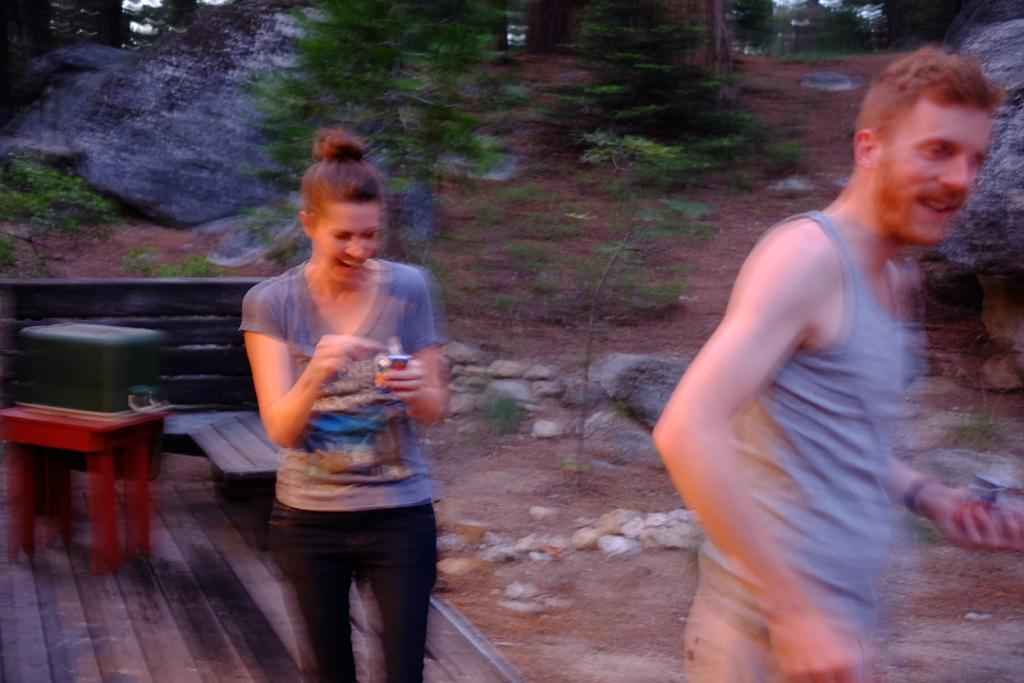Who is the main subject in the center of the image? There is a woman in the center of the image. What is the woman doing in the image? The woman is smiling. Who else is present in the image? There is a man on the right side of the image. What is the man doing in the image? The man is standing. What can be seen in the background of the image? There are trees in the background of the image. How many chickens are present in the image? There are no chickens present in the image. What type of crush is the woman holding in the image? There is no crush present in the image; the woman is simply smiling. 